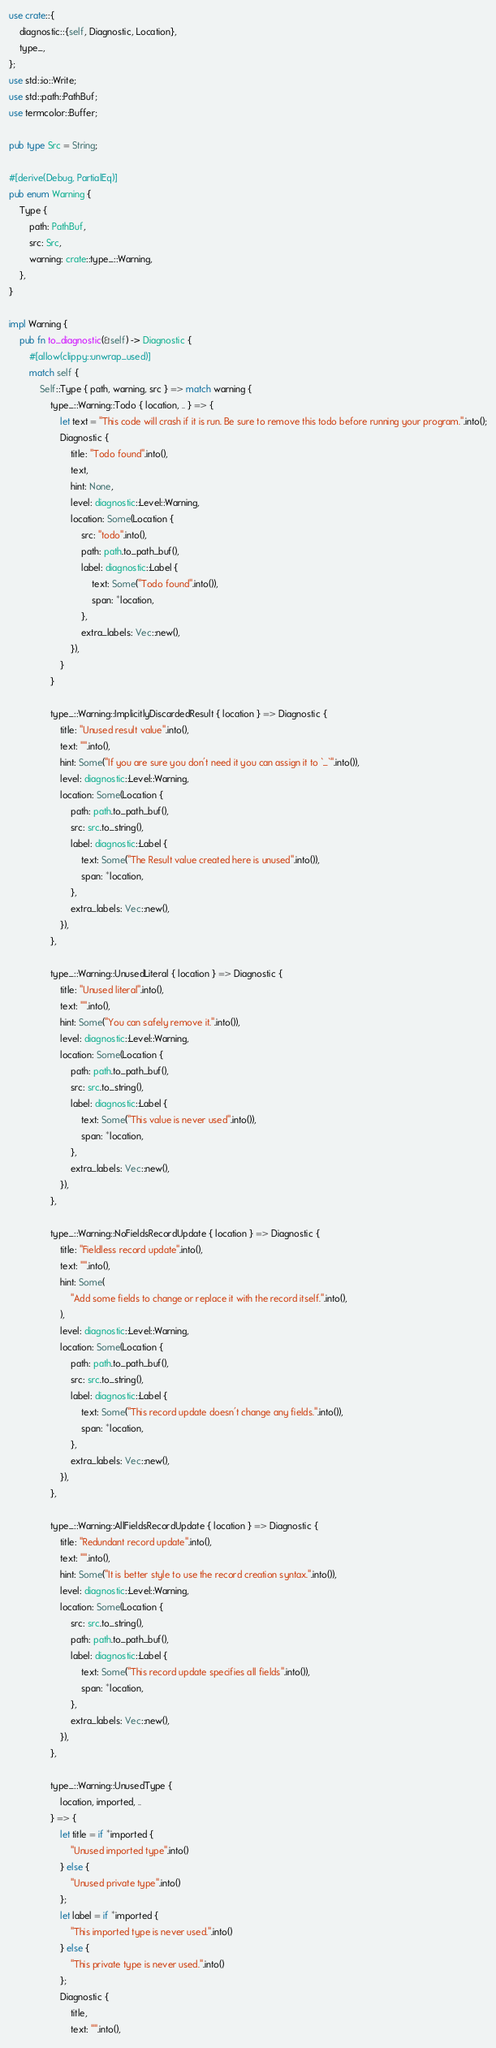<code> <loc_0><loc_0><loc_500><loc_500><_Rust_>use crate::{
    diagnostic::{self, Diagnostic, Location},
    type_,
};
use std::io::Write;
use std::path::PathBuf;
use termcolor::Buffer;

pub type Src = String;

#[derive(Debug, PartialEq)]
pub enum Warning {
    Type {
        path: PathBuf,
        src: Src,
        warning: crate::type_::Warning,
    },
}

impl Warning {
    pub fn to_diagnostic(&self) -> Diagnostic {
        #[allow(clippy::unwrap_used)]
        match self {
            Self::Type { path, warning, src } => match warning {
                type_::Warning::Todo { location, .. } => {
                    let text = "This code will crash if it is run. Be sure to remove this todo before running your program.".into();
                    Diagnostic {
                        title: "Todo found".into(),
                        text,
                        hint: None,
                        level: diagnostic::Level::Warning,
                        location: Some(Location {
                            src: "todo".into(),
                            path: path.to_path_buf(),
                            label: diagnostic::Label {
                                text: Some("Todo found".into()),
                                span: *location,
                            },
                            extra_labels: Vec::new(),
                        }),
                    }
                }

                type_::Warning::ImplicitlyDiscardedResult { location } => Diagnostic {
                    title: "Unused result value".into(),
                    text: "".into(),
                    hint: Some("If you are sure you don't need it you can assign it to `_`".into()),
                    level: diagnostic::Level::Warning,
                    location: Some(Location {
                        path: path.to_path_buf(),
                        src: src.to_string(),
                        label: diagnostic::Label {
                            text: Some("The Result value created here is unused".into()),
                            span: *location,
                        },
                        extra_labels: Vec::new(),
                    }),
                },

                type_::Warning::UnusedLiteral { location } => Diagnostic {
                    title: "Unused literal".into(),
                    text: "".into(),
                    hint: Some("You can safely remove it.".into()),
                    level: diagnostic::Level::Warning,
                    location: Some(Location {
                        path: path.to_path_buf(),
                        src: src.to_string(),
                        label: diagnostic::Label {
                            text: Some("This value is never used".into()),
                            span: *location,
                        },
                        extra_labels: Vec::new(),
                    }),
                },

                type_::Warning::NoFieldsRecordUpdate { location } => Diagnostic {
                    title: "Fieldless record update".into(),
                    text: "".into(),
                    hint: Some(
                        "Add some fields to change or replace it with the record itself.".into(),
                    ),
                    level: diagnostic::Level::Warning,
                    location: Some(Location {
                        path: path.to_path_buf(),
                        src: src.to_string(),
                        label: diagnostic::Label {
                            text: Some("This record update doesn't change any fields.".into()),
                            span: *location,
                        },
                        extra_labels: Vec::new(),
                    }),
                },

                type_::Warning::AllFieldsRecordUpdate { location } => Diagnostic {
                    title: "Redundant record update".into(),
                    text: "".into(),
                    hint: Some("It is better style to use the record creation syntax.".into()),
                    level: diagnostic::Level::Warning,
                    location: Some(Location {
                        src: src.to_string(),
                        path: path.to_path_buf(),
                        label: diagnostic::Label {
                            text: Some("This record update specifies all fields".into()),
                            span: *location,
                        },
                        extra_labels: Vec::new(),
                    }),
                },

                type_::Warning::UnusedType {
                    location, imported, ..
                } => {
                    let title = if *imported {
                        "Unused imported type".into()
                    } else {
                        "Unused private type".into()
                    };
                    let label = if *imported {
                        "This imported type is never used.".into()
                    } else {
                        "This private type is never used.".into()
                    };
                    Diagnostic {
                        title,
                        text: "".into(),</code> 